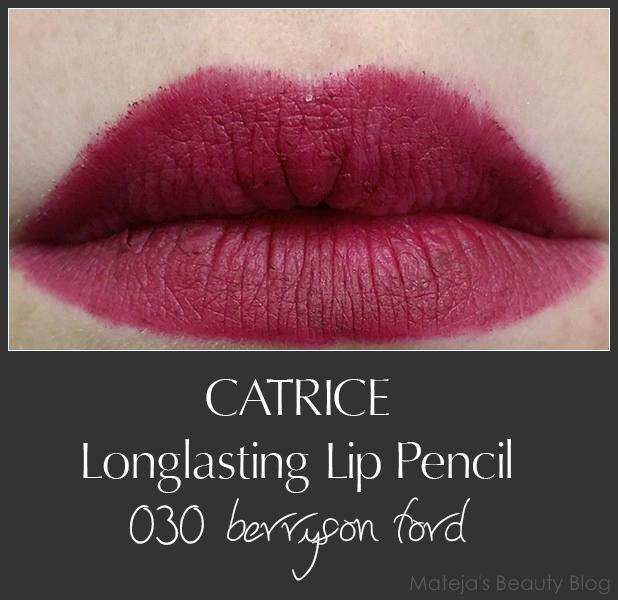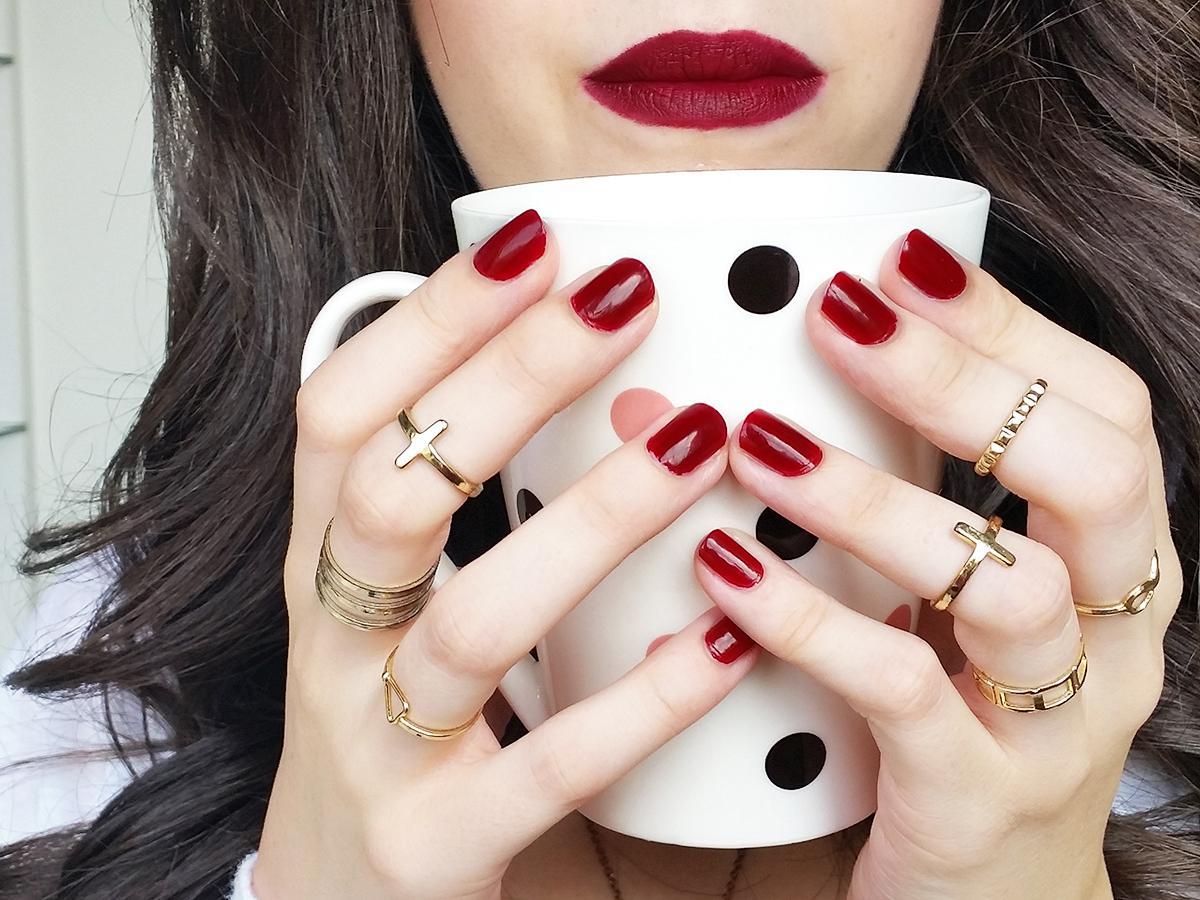The first image is the image on the left, the second image is the image on the right. For the images shown, is this caption "There is a woman wearing lipstick on the right image and swatches of lip products on the left." true? Answer yes or no. No. The first image is the image on the left, the second image is the image on the right. Evaluate the accuracy of this statement regarding the images: "One image includes multiple deep-red painted fingernails, and at least one image includes tinted lips.". Is it true? Answer yes or no. Yes. 